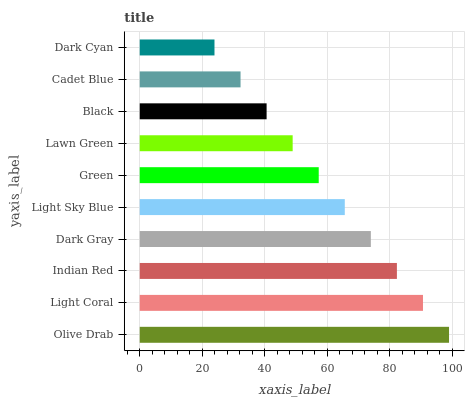Is Dark Cyan the minimum?
Answer yes or no. Yes. Is Olive Drab the maximum?
Answer yes or no. Yes. Is Light Coral the minimum?
Answer yes or no. No. Is Light Coral the maximum?
Answer yes or no. No. Is Olive Drab greater than Light Coral?
Answer yes or no. Yes. Is Light Coral less than Olive Drab?
Answer yes or no. Yes. Is Light Coral greater than Olive Drab?
Answer yes or no. No. Is Olive Drab less than Light Coral?
Answer yes or no. No. Is Light Sky Blue the high median?
Answer yes or no. Yes. Is Green the low median?
Answer yes or no. Yes. Is Green the high median?
Answer yes or no. No. Is Dark Gray the low median?
Answer yes or no. No. 